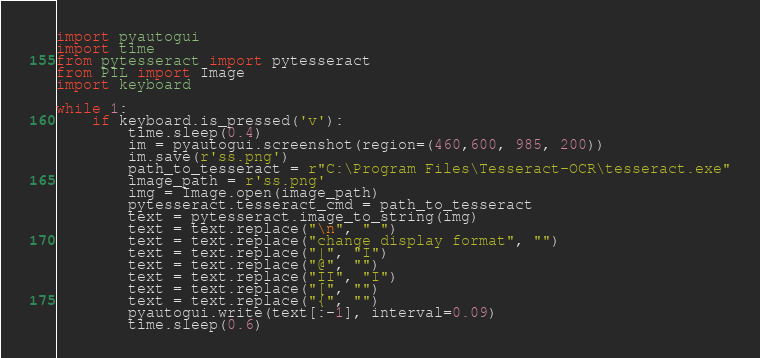Convert code to text. <code><loc_0><loc_0><loc_500><loc_500><_Python_>import pyautogui
import time
from pytesseract import pytesseract
from PIL import Image
import keyboard

while 1:
    if keyboard.is_pressed('v'):
        time.sleep(0.4)
        im = pyautogui.screenshot(region=(460,600, 985, 200))
        im.save(r'ss.png')
        path_to_tesseract = r"C:\Program Files\Tesseract-OCR\tesseract.exe"
        image_path = r'ss.png'
        img = Image.open(image_path)
        pytesseract.tesseract_cmd = path_to_tesseract
        text = pytesseract.image_to_string(img)
        text = text.replace("\n", " ")
        text = text.replace("change display format", "")
        text = text.replace("|", "I")
        text = text.replace("@", "")
        text = text.replace("II", "I")
        text = text.replace("[", "")
        text = text.replace("{", "")
        pyautogui.write(text[:-1], interval=0.09)
        time.sleep(0.6)
</code> 